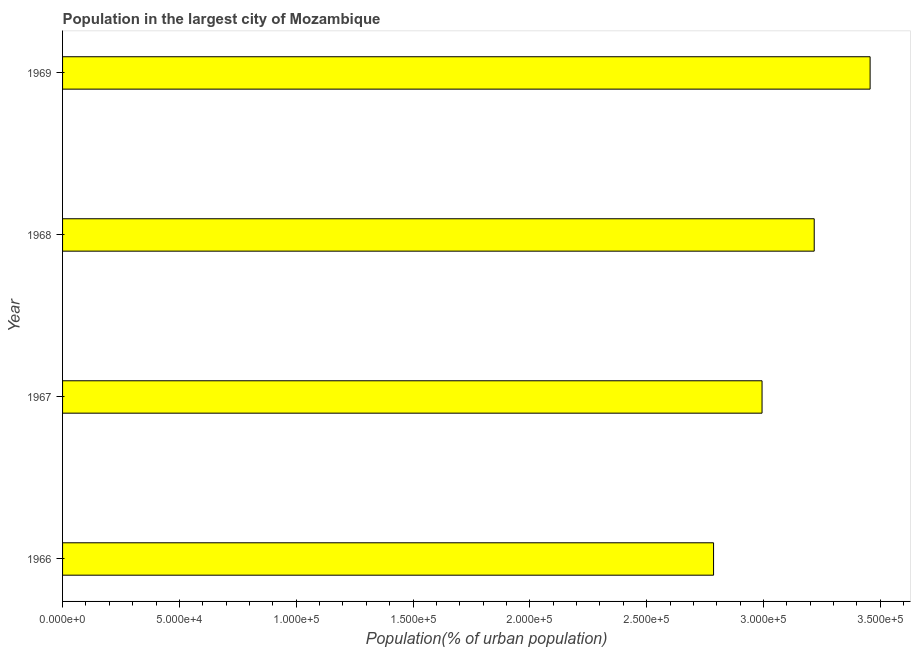Does the graph contain any zero values?
Your answer should be very brief. No. What is the title of the graph?
Provide a succinct answer. Population in the largest city of Mozambique. What is the label or title of the X-axis?
Keep it short and to the point. Population(% of urban population). What is the population in largest city in 1969?
Your answer should be compact. 3.46e+05. Across all years, what is the maximum population in largest city?
Keep it short and to the point. 3.46e+05. Across all years, what is the minimum population in largest city?
Your answer should be compact. 2.79e+05. In which year was the population in largest city maximum?
Provide a short and direct response. 1969. In which year was the population in largest city minimum?
Give a very brief answer. 1966. What is the sum of the population in largest city?
Offer a terse response. 1.25e+06. What is the difference between the population in largest city in 1966 and 1967?
Offer a terse response. -2.08e+04. What is the average population in largest city per year?
Provide a short and direct response. 3.11e+05. What is the median population in largest city?
Offer a very short reply. 3.11e+05. What is the ratio of the population in largest city in 1966 to that in 1968?
Make the answer very short. 0.87. What is the difference between the highest and the second highest population in largest city?
Your response must be concise. 2.39e+04. What is the difference between the highest and the lowest population in largest city?
Your answer should be very brief. 6.70e+04. How many bars are there?
Offer a very short reply. 4. Are all the bars in the graph horizontal?
Your response must be concise. Yes. How many years are there in the graph?
Your response must be concise. 4. What is the difference between two consecutive major ticks on the X-axis?
Your answer should be compact. 5.00e+04. Are the values on the major ticks of X-axis written in scientific E-notation?
Provide a succinct answer. Yes. What is the Population(% of urban population) of 1966?
Your answer should be compact. 2.79e+05. What is the Population(% of urban population) of 1967?
Give a very brief answer. 2.99e+05. What is the Population(% of urban population) of 1968?
Your answer should be compact. 3.22e+05. What is the Population(% of urban population) of 1969?
Your answer should be very brief. 3.46e+05. What is the difference between the Population(% of urban population) in 1966 and 1967?
Your response must be concise. -2.08e+04. What is the difference between the Population(% of urban population) in 1966 and 1968?
Ensure brevity in your answer.  -4.31e+04. What is the difference between the Population(% of urban population) in 1966 and 1969?
Make the answer very short. -6.70e+04. What is the difference between the Population(% of urban population) in 1967 and 1968?
Provide a short and direct response. -2.23e+04. What is the difference between the Population(% of urban population) in 1967 and 1969?
Provide a short and direct response. -4.63e+04. What is the difference between the Population(% of urban population) in 1968 and 1969?
Your answer should be compact. -2.39e+04. What is the ratio of the Population(% of urban population) in 1966 to that in 1967?
Your answer should be very brief. 0.93. What is the ratio of the Population(% of urban population) in 1966 to that in 1968?
Offer a terse response. 0.87. What is the ratio of the Population(% of urban population) in 1966 to that in 1969?
Offer a terse response. 0.81. What is the ratio of the Population(% of urban population) in 1967 to that in 1968?
Give a very brief answer. 0.93. What is the ratio of the Population(% of urban population) in 1967 to that in 1969?
Offer a very short reply. 0.87. What is the ratio of the Population(% of urban population) in 1968 to that in 1969?
Offer a terse response. 0.93. 